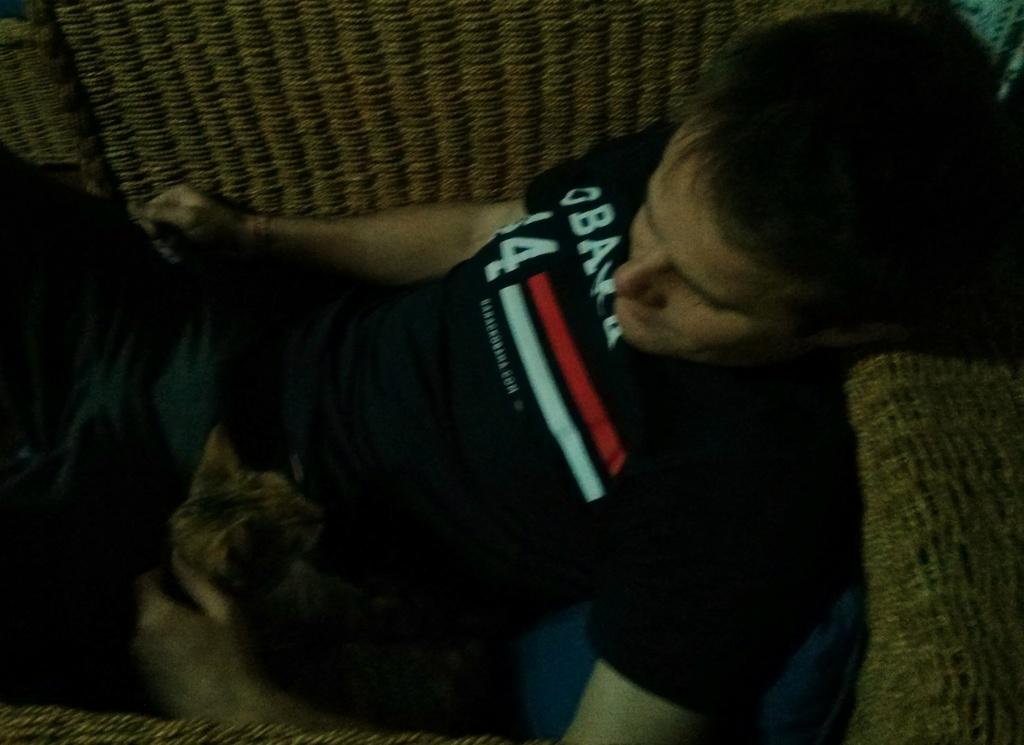Who is present in the image? There is a man in the image. What is the man wearing? The man is wearing a black t-shirt. What is the man's position in the image? The man is laying on a couch. Are there any animals in the image? Yes, there is a cat in the image. What is the man doing with the cat? The man is holding the cat. What type of toys can be seen in the image? There are no toys present in the image. What design is featured on the man's t-shirt? The provided facts do not mention any design on the man's t-shirt; it only states that he is wearing a black t-shirt. 